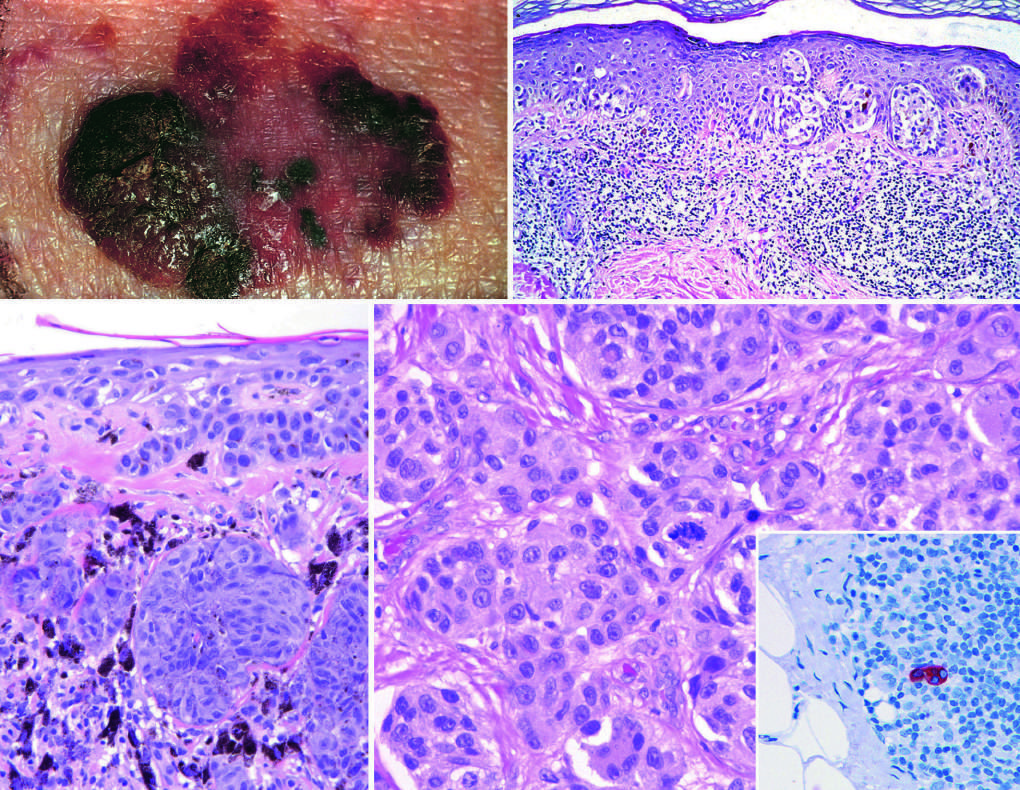does the inset show a sentinel lymph node containing a tiny cluster of metastatic melanoma, detected by staining for the melanocytic marker hmb-45?
Answer the question using a single word or phrase. Yes 